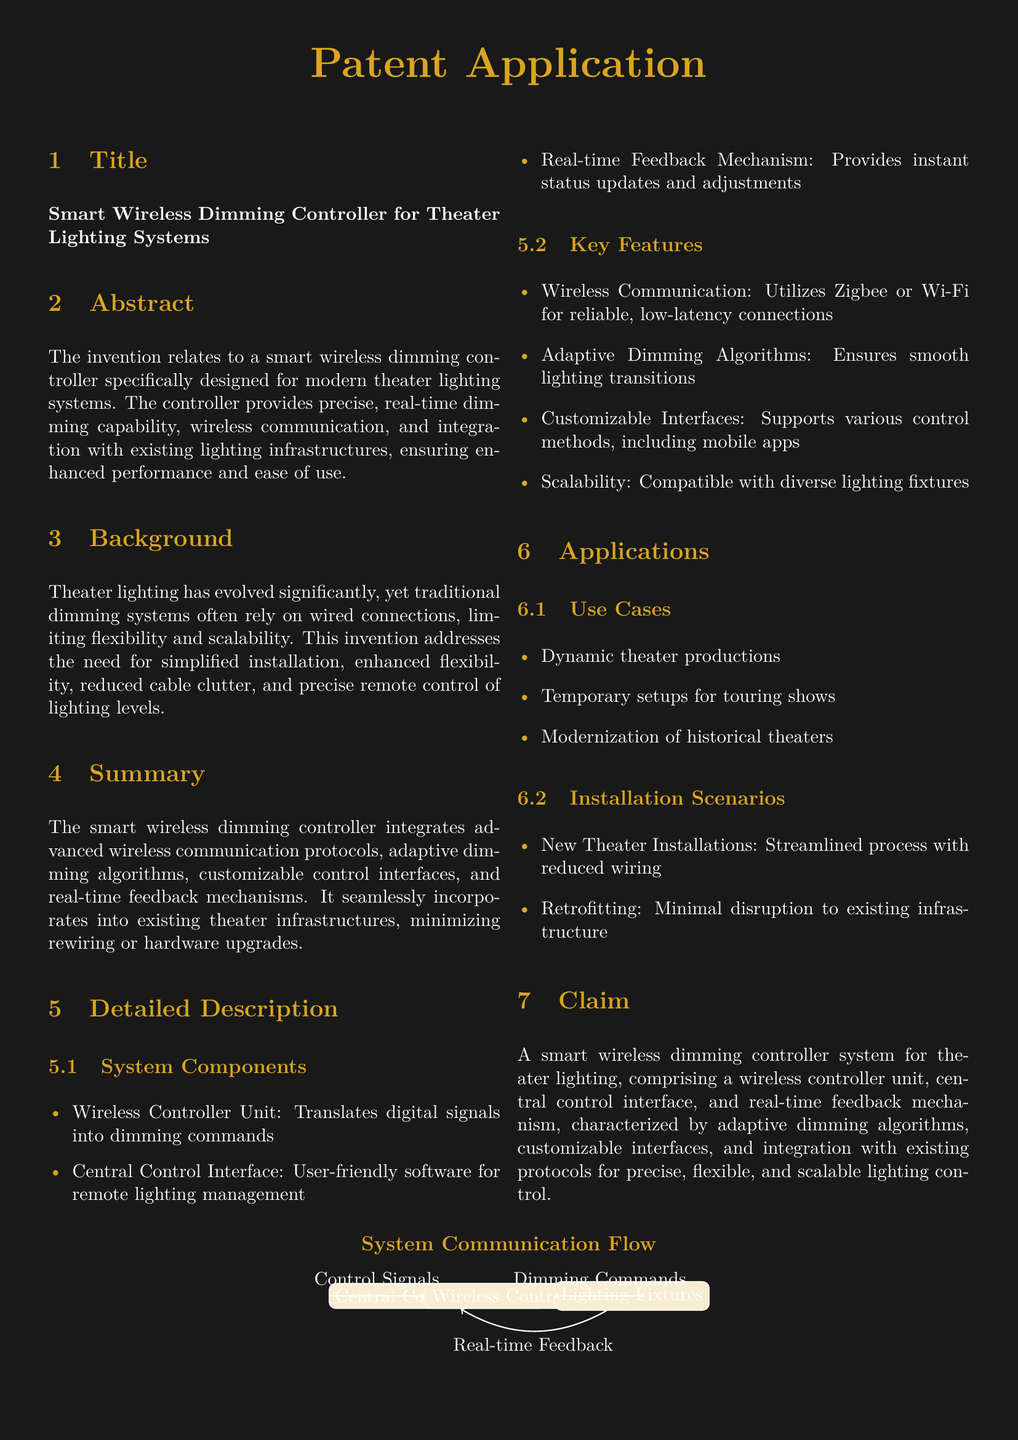What is the title of the patent? The title of the patent is presented in the document section labeled "Title."
Answer: Smart Wireless Dimming Controller for Theater Lighting Systems What is the main purpose of the Smart Wireless Dimming Controller? The main purpose is summarized in the abstract section, which describes its functionality.
Answer: Precise, real-time dimming capability What wireless communication protocols does the controller utilize? The key features section lists the technologies used for communication.
Answer: Zigbee or Wi-Fi What type of interface does the system offer for user management? The system components section highlights the type of software available for control.
Answer: Central Control Interface In what scenario is this dimming controller most suitable? The applications section presents specific contexts where the controller can be applied.
Answer: Dynamic theater productions How many components are listed in the system description? The system components section details the units involved in the system.
Answer: Three What is the claimed feature of the smart wireless dimming controller? The claim section specifies the unique aspects of the invention that are protected.
Answer: Adaptive dimming algorithms What benefit does the controller provide for retrofitting? The installation scenarios section mentions advantages for existing setups.
Answer: Minimal disruption to existing infrastructure What does the real-time feedback mechanism provide? The detailed description of system components indicates what the mechanism does.
Answer: Instant status updates and adjustments 